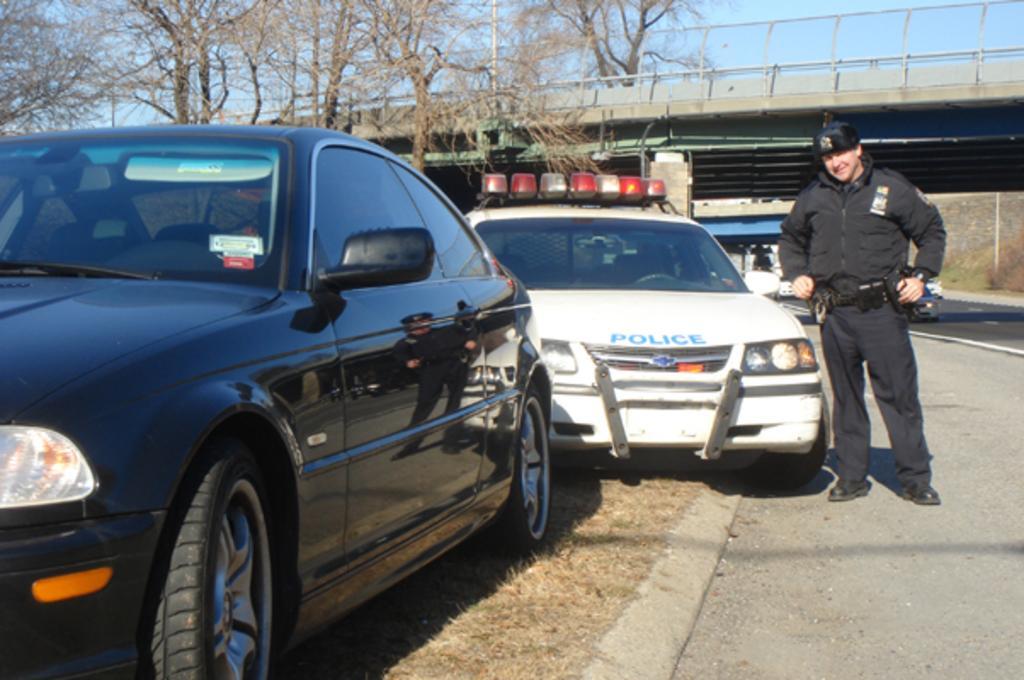Can you describe this image briefly? In this picture we can see a man in the black jacket and he is standing on the road. On the left side of the man there are two cars. Behind the man there are trees, a bridge and there are some vehicles on the road. Behind the bridge there is the sky. 